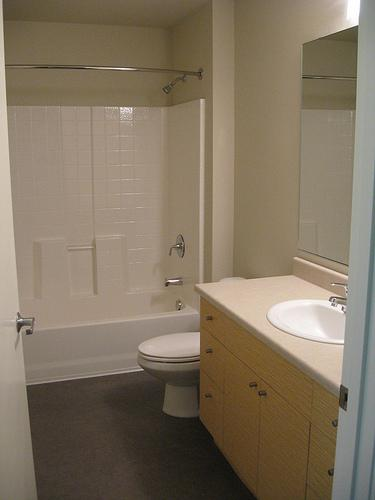Question: why is it so bright?
Choices:
A. Sun is shining.
B. Candles are lit.
C. Lights are on.
D. Flashlights are on.
Answer with the letter. Answer: C Question: what color is the floor?
Choices:
A. Purple.
B. Gray.
C. Black.
D. Brown.
Answer with the letter. Answer: B Question: what are the cabinets made of?
Choices:
A. Plastic.
B. Bamboo.
C. Wood.
D. Metal.
Answer with the letter. Answer: C Question: where is the photo taken?
Choices:
A. In a closet.
B. In a kitchen.
C. In a bedroom.
D. In a bathroom.
Answer with the letter. Answer: D Question: when is the photo taken?
Choices:
A. Early morning.
B. Night time.
C. Noon.
D. Midnight.
Answer with the letter. Answer: B 